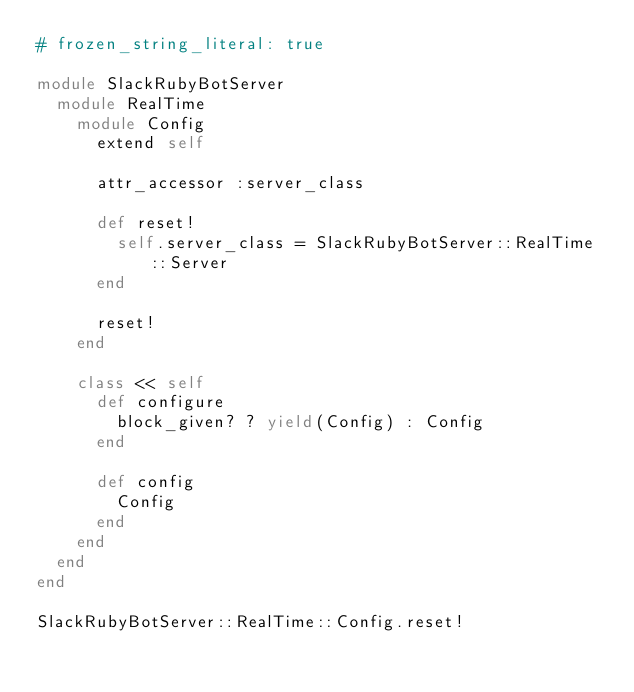Convert code to text. <code><loc_0><loc_0><loc_500><loc_500><_Ruby_># frozen_string_literal: true

module SlackRubyBotServer
  module RealTime
    module Config
      extend self

      attr_accessor :server_class

      def reset!
        self.server_class = SlackRubyBotServer::RealTime::Server
      end

      reset!
    end

    class << self
      def configure
        block_given? ? yield(Config) : Config
      end

      def config
        Config
      end
    end
  end
end

SlackRubyBotServer::RealTime::Config.reset!
</code> 